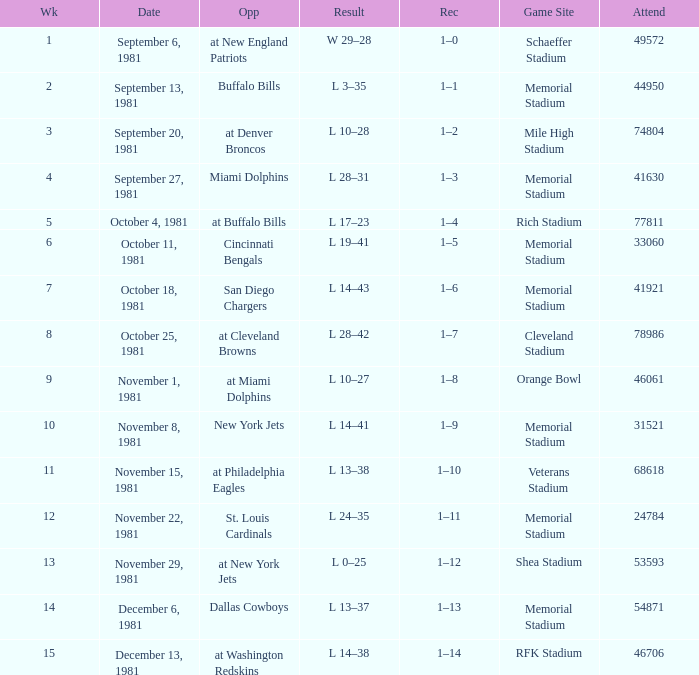When it is October 18, 1981 where is the game site? Memorial Stadium. 